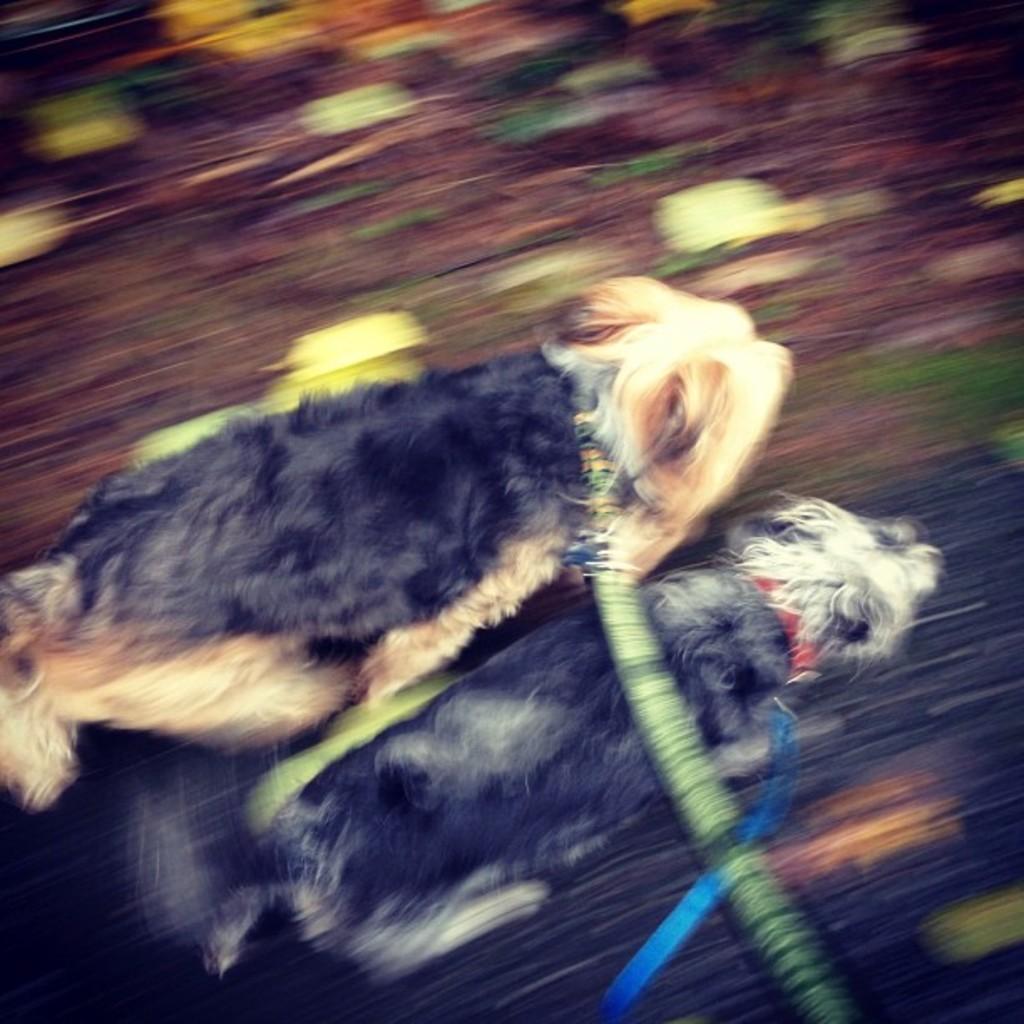Please provide a concise description of this image. It is a blur image. In this image, we can see two dogs and belts. 